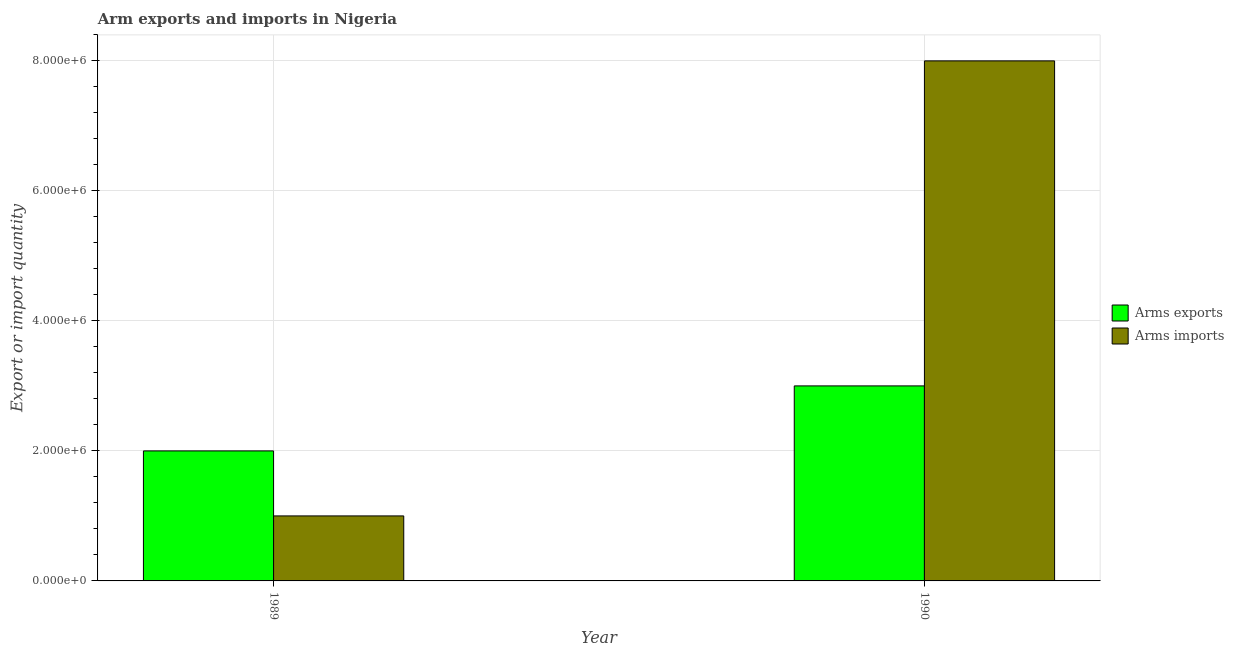Are the number of bars on each tick of the X-axis equal?
Offer a very short reply. Yes. How many bars are there on the 1st tick from the left?
Your response must be concise. 2. How many bars are there on the 1st tick from the right?
Your response must be concise. 2. What is the label of the 1st group of bars from the left?
Give a very brief answer. 1989. What is the arms imports in 1989?
Your response must be concise. 1.00e+06. Across all years, what is the maximum arms exports?
Your response must be concise. 3.00e+06. Across all years, what is the minimum arms imports?
Provide a short and direct response. 1.00e+06. What is the total arms exports in the graph?
Your answer should be very brief. 5.00e+06. What is the difference between the arms exports in 1989 and that in 1990?
Your response must be concise. -1.00e+06. What is the difference between the arms exports in 1990 and the arms imports in 1989?
Your answer should be compact. 1.00e+06. What is the average arms imports per year?
Your answer should be compact. 4.50e+06. In how many years, is the arms exports greater than 1200000?
Provide a short and direct response. 2. What is the ratio of the arms exports in 1989 to that in 1990?
Offer a very short reply. 0.67. Is the arms exports in 1989 less than that in 1990?
Provide a succinct answer. Yes. What does the 1st bar from the left in 1989 represents?
Make the answer very short. Arms exports. What does the 1st bar from the right in 1990 represents?
Make the answer very short. Arms imports. How many bars are there?
Provide a succinct answer. 4. What is the difference between two consecutive major ticks on the Y-axis?
Ensure brevity in your answer.  2.00e+06. Are the values on the major ticks of Y-axis written in scientific E-notation?
Keep it short and to the point. Yes. How are the legend labels stacked?
Keep it short and to the point. Vertical. What is the title of the graph?
Make the answer very short. Arm exports and imports in Nigeria. Does "Registered firms" appear as one of the legend labels in the graph?
Ensure brevity in your answer.  No. What is the label or title of the Y-axis?
Provide a succinct answer. Export or import quantity. What is the Export or import quantity in Arms exports in 1989?
Your answer should be compact. 2.00e+06. What is the Export or import quantity in Arms imports in 1989?
Your answer should be compact. 1.00e+06. What is the Export or import quantity in Arms exports in 1990?
Your response must be concise. 3.00e+06. What is the Export or import quantity in Arms imports in 1990?
Keep it short and to the point. 8.00e+06. Across all years, what is the maximum Export or import quantity of Arms imports?
Provide a succinct answer. 8.00e+06. Across all years, what is the minimum Export or import quantity in Arms exports?
Ensure brevity in your answer.  2.00e+06. Across all years, what is the minimum Export or import quantity of Arms imports?
Your answer should be compact. 1.00e+06. What is the total Export or import quantity of Arms imports in the graph?
Your response must be concise. 9.00e+06. What is the difference between the Export or import quantity of Arms imports in 1989 and that in 1990?
Give a very brief answer. -7.00e+06. What is the difference between the Export or import quantity in Arms exports in 1989 and the Export or import quantity in Arms imports in 1990?
Keep it short and to the point. -6.00e+06. What is the average Export or import quantity in Arms exports per year?
Provide a succinct answer. 2.50e+06. What is the average Export or import quantity in Arms imports per year?
Your response must be concise. 4.50e+06. In the year 1989, what is the difference between the Export or import quantity in Arms exports and Export or import quantity in Arms imports?
Provide a short and direct response. 1.00e+06. In the year 1990, what is the difference between the Export or import quantity in Arms exports and Export or import quantity in Arms imports?
Offer a terse response. -5.00e+06. What is the ratio of the Export or import quantity of Arms exports in 1989 to that in 1990?
Your answer should be compact. 0.67. What is the difference between the highest and the second highest Export or import quantity in Arms exports?
Offer a terse response. 1.00e+06. What is the difference between the highest and the second highest Export or import quantity of Arms imports?
Your answer should be very brief. 7.00e+06. 